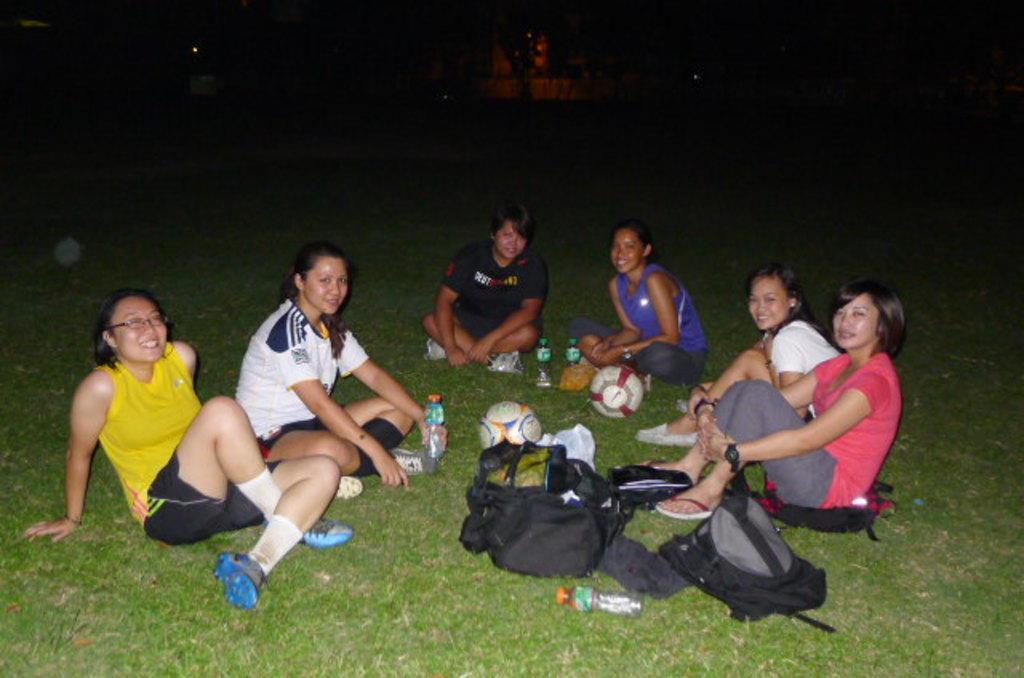In one or two sentences, can you explain what this image depicts? In this image we can see few ladies sitting on the ground. On the ground there is grass. Also there are bottles, balls, bags and few other items. In the background it is dark. 